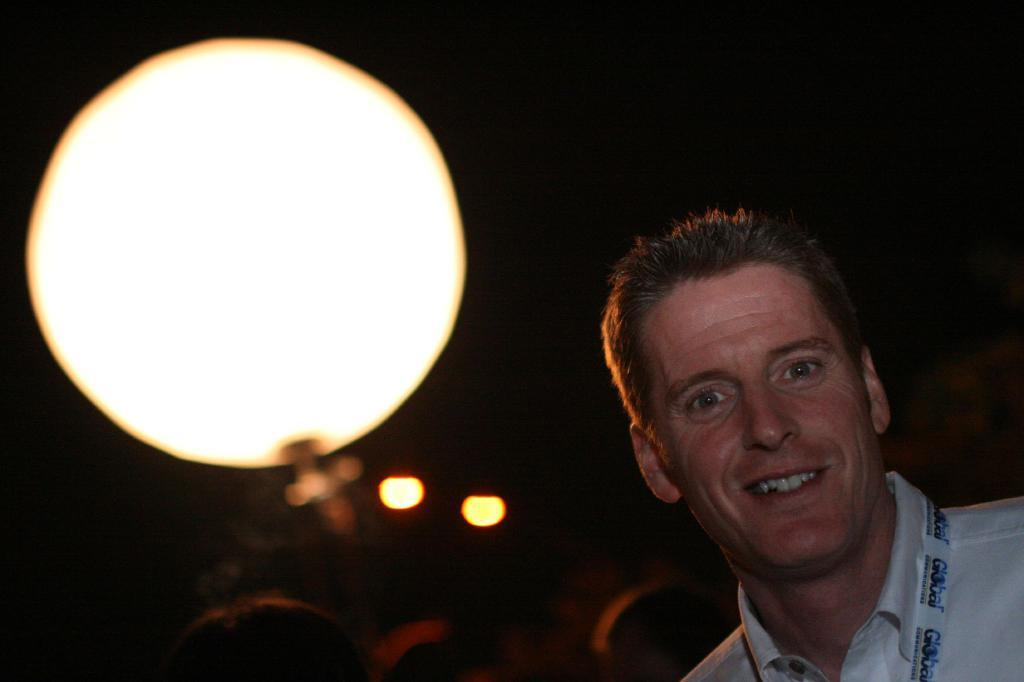Where is the person located in the image? The person is in the bottom right corner of the image. What is the person's facial expression in the image? The person is smiling in the image. Can you describe the background of the image? The background of the image is blurred. What is the main object in the middle of the image? There is a white color object in the middle of the image. What type of apple is being used to stop the car in the image? There is no car or apple present in the image, so it is not possible to determine if an apple is being used to stop a car. 